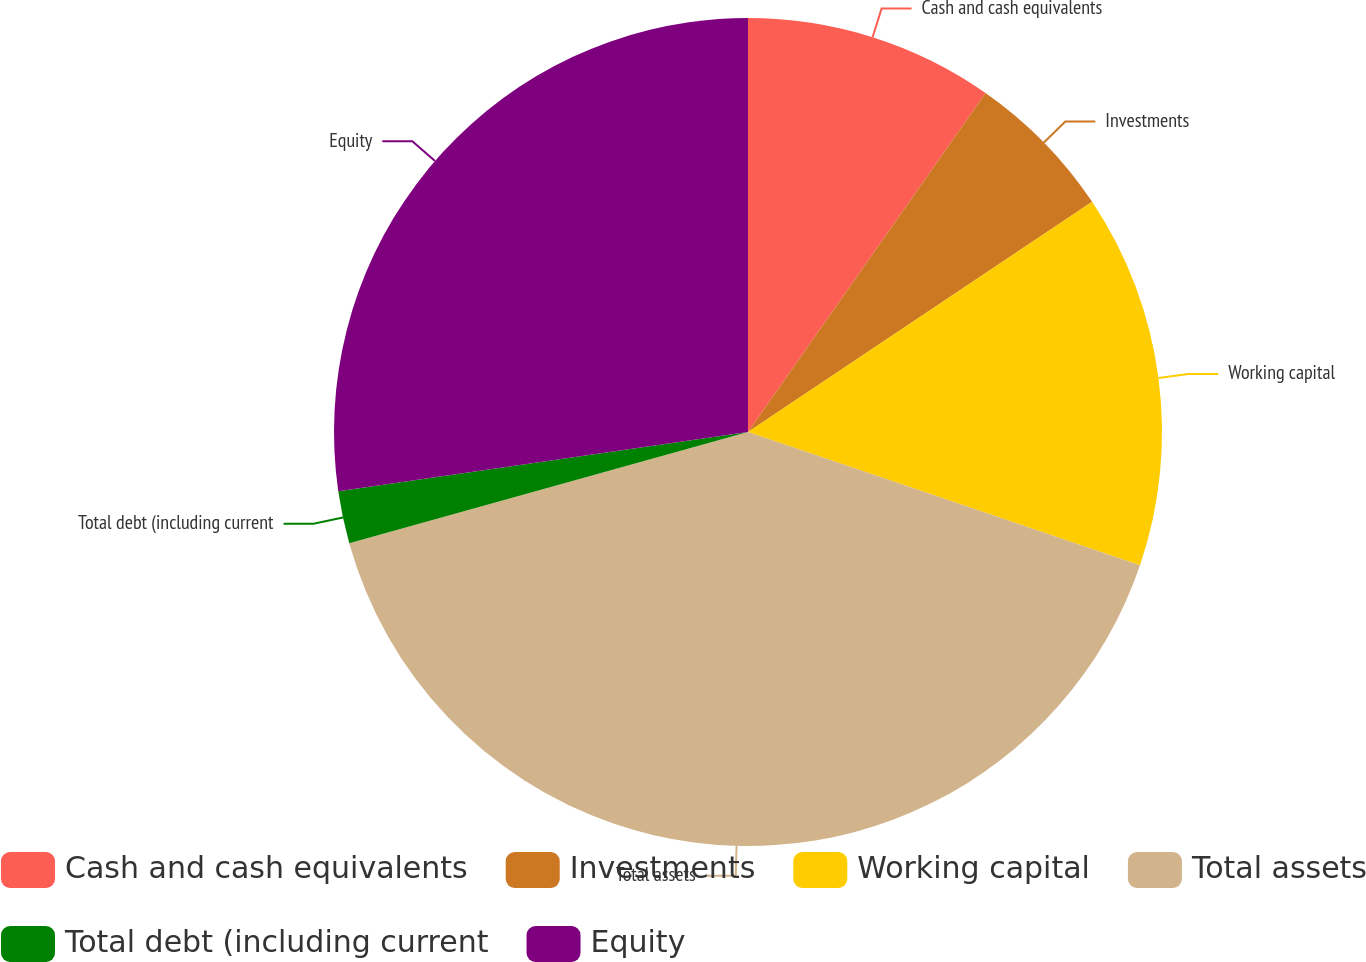Convert chart to OTSL. <chart><loc_0><loc_0><loc_500><loc_500><pie_chart><fcel>Cash and cash equivalents<fcel>Investments<fcel>Working capital<fcel>Total assets<fcel>Total debt (including current<fcel>Equity<nl><fcel>9.73%<fcel>5.89%<fcel>14.6%<fcel>40.46%<fcel>2.05%<fcel>27.29%<nl></chart> 